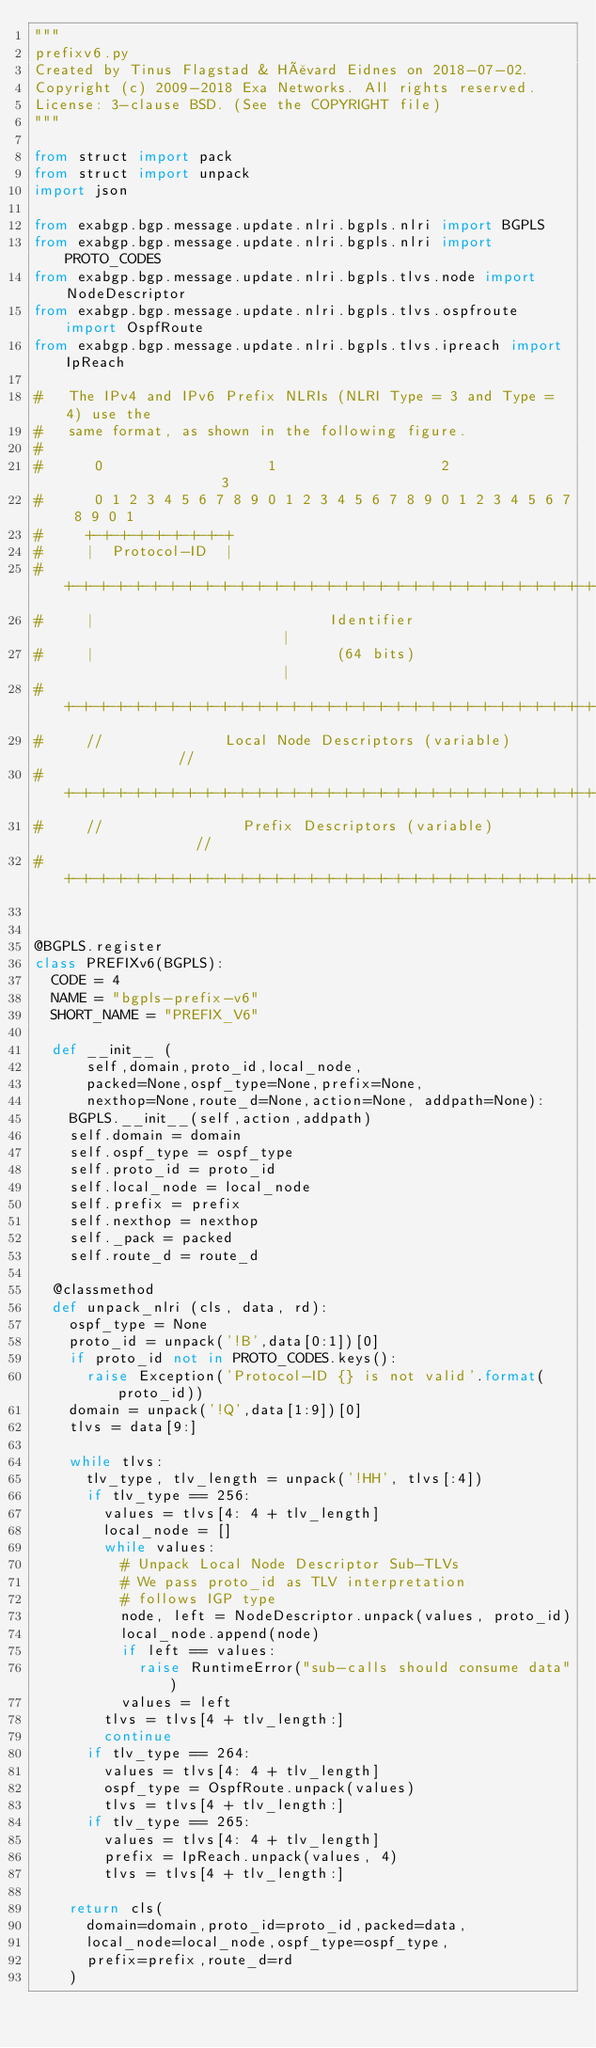<code> <loc_0><loc_0><loc_500><loc_500><_Python_>"""
prefixv6.py
Created by Tinus Flagstad & Håvard Eidnes on 2018-07-02.
Copyright (c) 2009-2018 Exa Networks. All rights reserved.
License: 3-clause BSD. (See the COPYRIGHT file)
"""

from struct import pack
from struct import unpack
import json

from exabgp.bgp.message.update.nlri.bgpls.nlri import BGPLS
from exabgp.bgp.message.update.nlri.bgpls.nlri import PROTO_CODES
from exabgp.bgp.message.update.nlri.bgpls.tlvs.node import NodeDescriptor
from exabgp.bgp.message.update.nlri.bgpls.tlvs.ospfroute import OspfRoute
from exabgp.bgp.message.update.nlri.bgpls.tlvs.ipreach import IpReach

#   The IPv4 and IPv6 Prefix NLRIs (NLRI Type = 3 and Type = 4) use the
#   same format, as shown in the following figure.
#
#      0                   1                   2                   3
#      0 1 2 3 4 5 6 7 8 9 0 1 2 3 4 5 6 7 8 9 0 1 2 3 4 5 6 7 8 9 0 1
#     +-+-+-+-+-+-+-+-+
#     |  Protocol-ID  |
#     +-+-+-+-+-+-+-+-+-+-+-+-+-+-+-+-+-+-+-+-+-+-+-+-+-+-+-+-+-+-+-+-+
#     |                           Identifier                          |
#     |                            (64 bits)                          |
#     +-+-+-+-+-+-+-+-+-+-+-+-+-+-+-+-+-+-+-+-+-+-+-+-+-+-+-+-+-+-+-+-+
#     //              Local Node Descriptors (variable)              //
#     +-+-+-+-+-+-+-+-+-+-+-+-+-+-+-+-+-+-+-+-+-+-+-+-+-+-+-+-+-+-+-+-+
#     //                Prefix Descriptors (variable)                //
#     +-+-+-+-+-+-+-+-+-+-+-+-+-+-+-+-+-+-+-+-+-+-+-+-+-+-+-+-+-+-+-+-+


@BGPLS.register
class PREFIXv6(BGPLS):
	CODE = 4
	NAME = "bgpls-prefix-v6"
	SHORT_NAME = "PREFIX_V6"

	def __init__ (
			self,domain,proto_id,local_node,
			packed=None,ospf_type=None,prefix=None,
			nexthop=None,route_d=None,action=None, addpath=None):
		BGPLS.__init__(self,action,addpath)
		self.domain = domain
		self.ospf_type = ospf_type
		self.proto_id = proto_id
		self.local_node = local_node
		self.prefix = prefix
		self.nexthop = nexthop
		self._pack = packed
		self.route_d = route_d

	@classmethod
	def unpack_nlri (cls, data, rd):
		ospf_type = None
		proto_id = unpack('!B',data[0:1])[0]
		if proto_id not in PROTO_CODES.keys():
			raise Exception('Protocol-ID {} is not valid'.format(proto_id))
		domain = unpack('!Q',data[1:9])[0]
		tlvs = data[9:]

		while tlvs:
			tlv_type, tlv_length = unpack('!HH', tlvs[:4])
			if tlv_type == 256:
				values = tlvs[4: 4 + tlv_length]
				local_node = []
				while values:
					# Unpack Local Node Descriptor Sub-TLVs
					# We pass proto_id as TLV interpretation
					# follows IGP type
					node, left = NodeDescriptor.unpack(values, proto_id)
					local_node.append(node)
					if left == values:
						raise RuntimeError("sub-calls should consume data")
					values = left
				tlvs = tlvs[4 + tlv_length:]
				continue
			if tlv_type == 264:
				values = tlvs[4: 4 + tlv_length]
				ospf_type = OspfRoute.unpack(values)
				tlvs = tlvs[4 + tlv_length:]
			if tlv_type == 265:
				values = tlvs[4: 4 + tlv_length]
				prefix = IpReach.unpack(values, 4)
				tlvs = tlvs[4 + tlv_length:]

		return cls(
			domain=domain,proto_id=proto_id,packed=data,
			local_node=local_node,ospf_type=ospf_type,
			prefix=prefix,route_d=rd
		)
</code> 